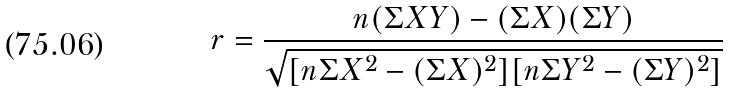Convert formula to latex. <formula><loc_0><loc_0><loc_500><loc_500>r = \frac { n ( \Sigma X Y ) - ( \Sigma X ) ( \Sigma Y ) } { \sqrt { [ n \Sigma X ^ { 2 } - ( \Sigma X ) ^ { 2 } ] [ n \Sigma Y ^ { 2 } - ( \Sigma Y ) ^ { 2 } ] } }</formula> 